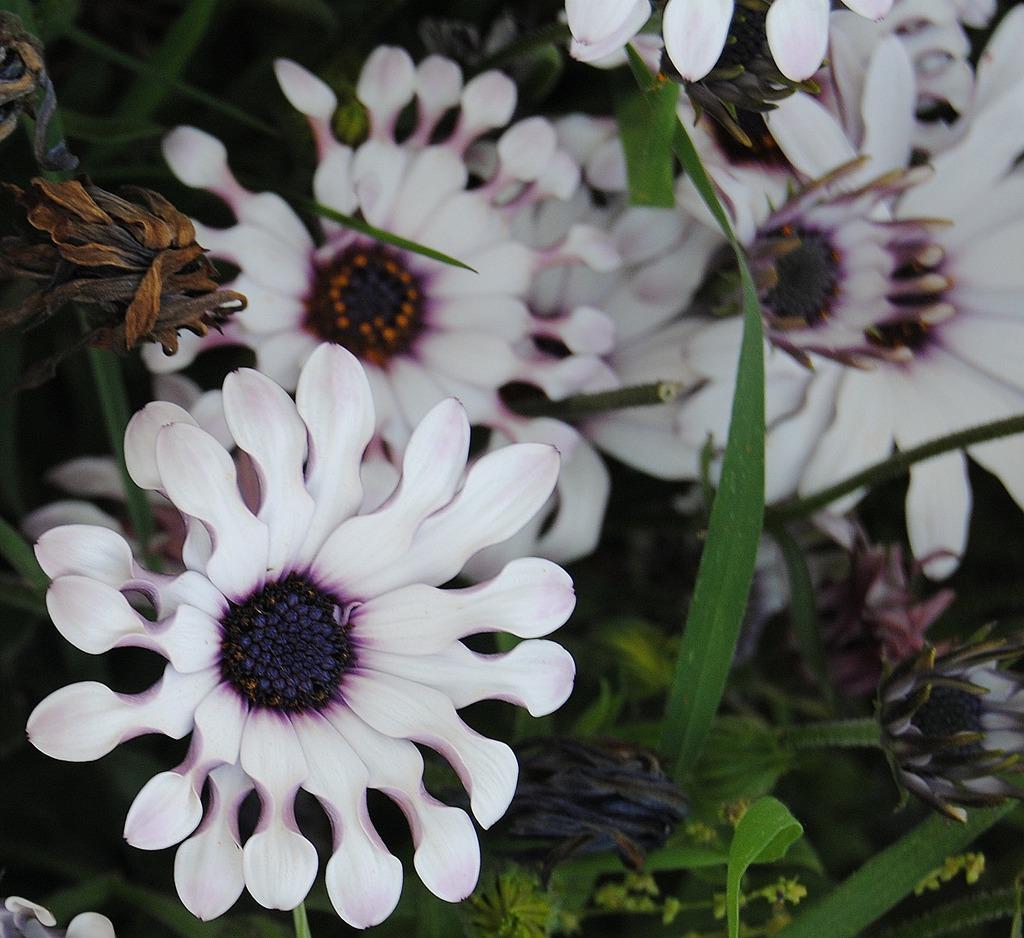Please provide a concise description of this image. in this image I can see white color flowers and I can see leaves visible in between flowers. 